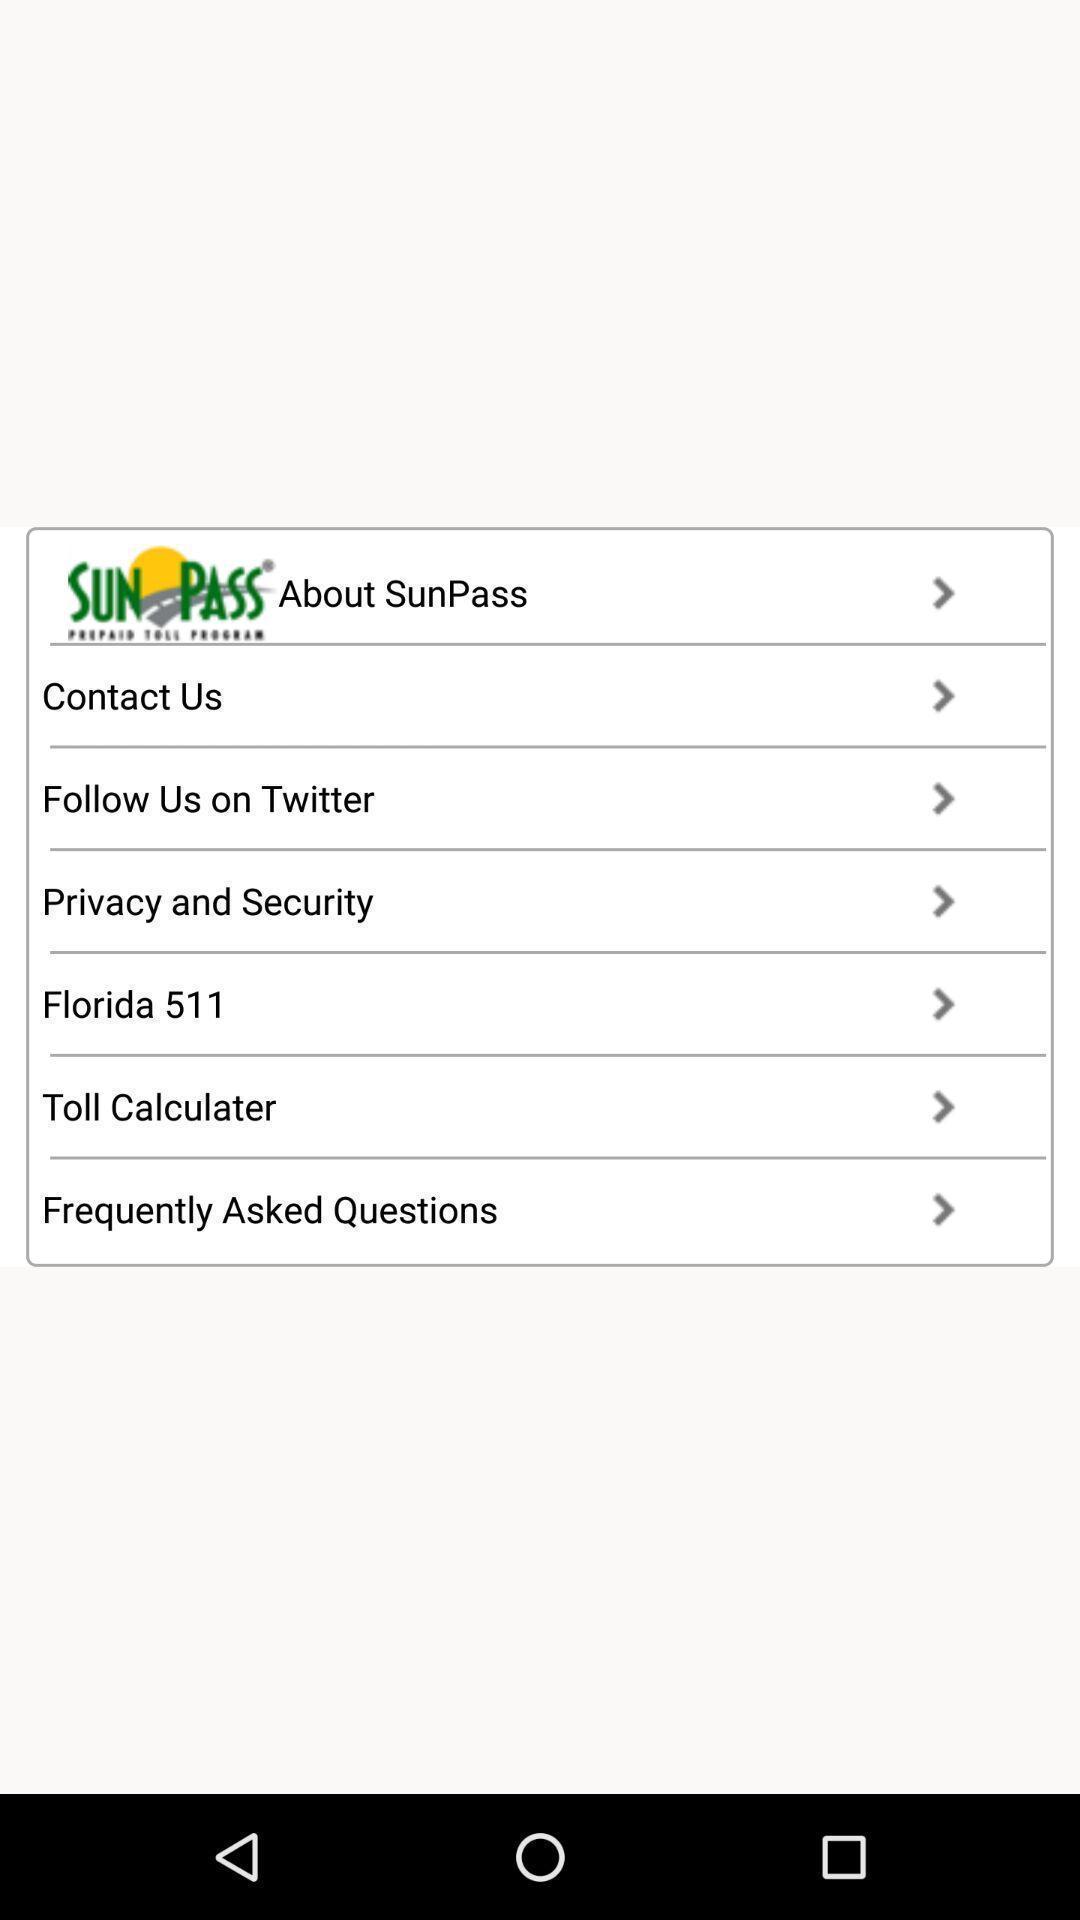Tell me about the visual elements in this screen capture. Popup showing different options to choose. 